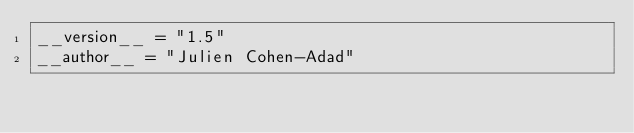<code> <loc_0><loc_0><loc_500><loc_500><_Python_>__version__ = "1.5"
__author__ = "Julien Cohen-Adad"</code> 